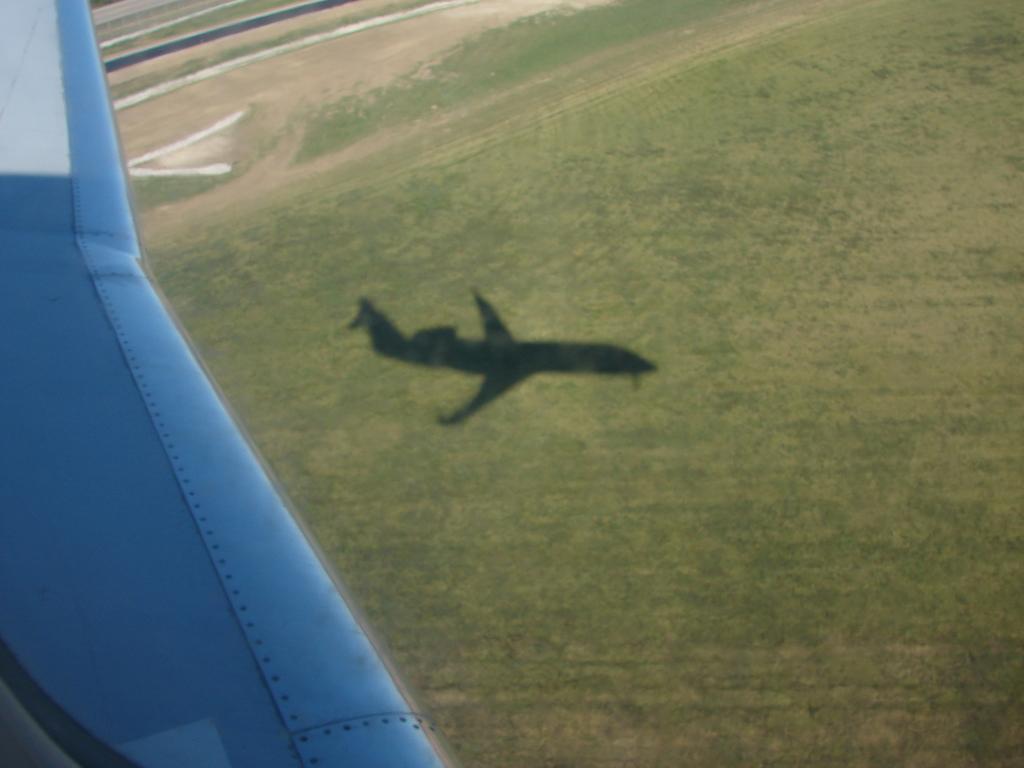Please provide a concise description of this image. In the picture we can see an Aerial view from the flight, which is blue in color and to the ground we can see a grass and a flight shadow. 